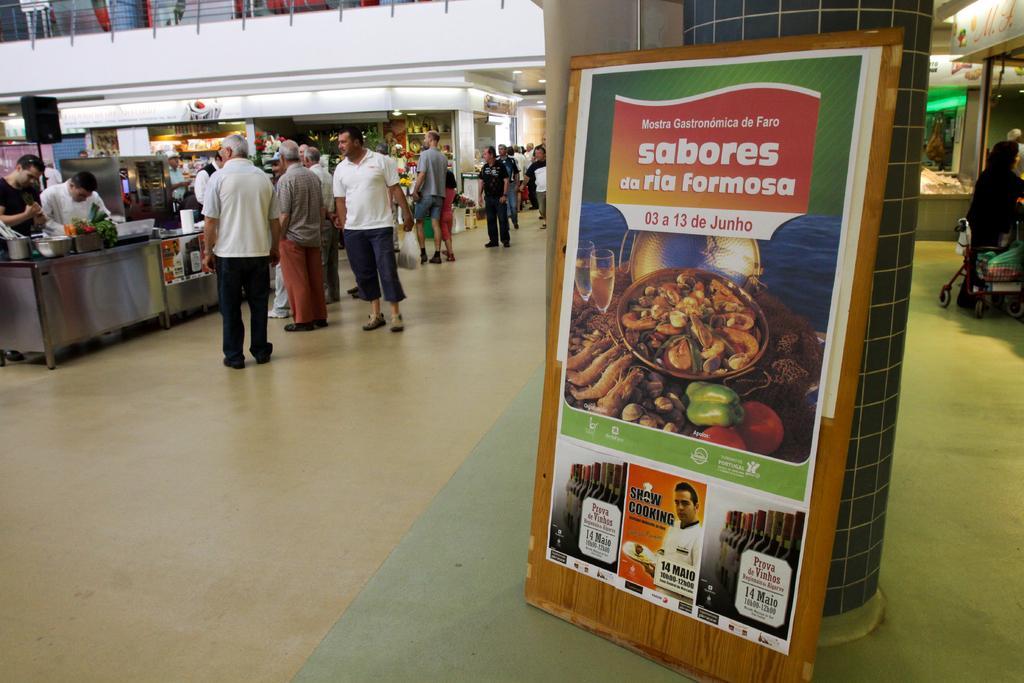Please provide a concise description of this image. In this picture I can observe some people standing on the floor. On the right side I can observe advertisement board. In the background I can observe stalls. 